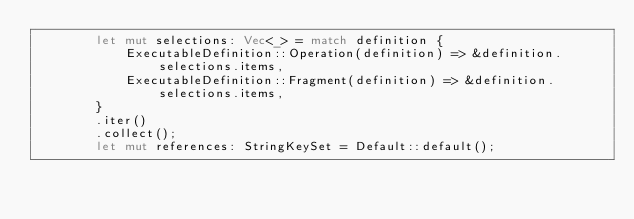Convert code to text. <code><loc_0><loc_0><loc_500><loc_500><_Rust_>        let mut selections: Vec<_> = match definition {
            ExecutableDefinition::Operation(definition) => &definition.selections.items,
            ExecutableDefinition::Fragment(definition) => &definition.selections.items,
        }
        .iter()
        .collect();
        let mut references: StringKeySet = Default::default();</code> 